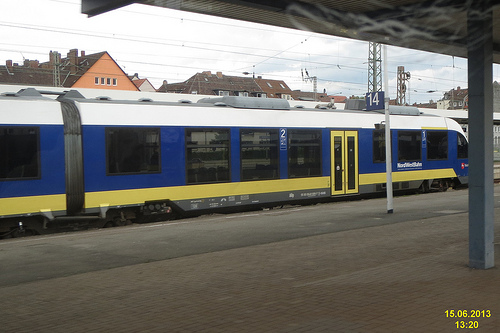Are there both a window and a door in this picture? Yes, train cars typically have both windows and doors, which are visible here, allowing passenger access and visibility. 